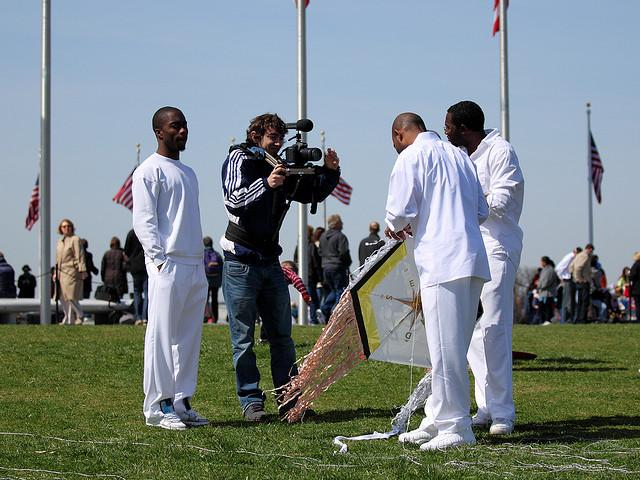What is the occupation of the man holding a camera? Please explain your reasoning. reporter. Most reporters move around with cameras. 